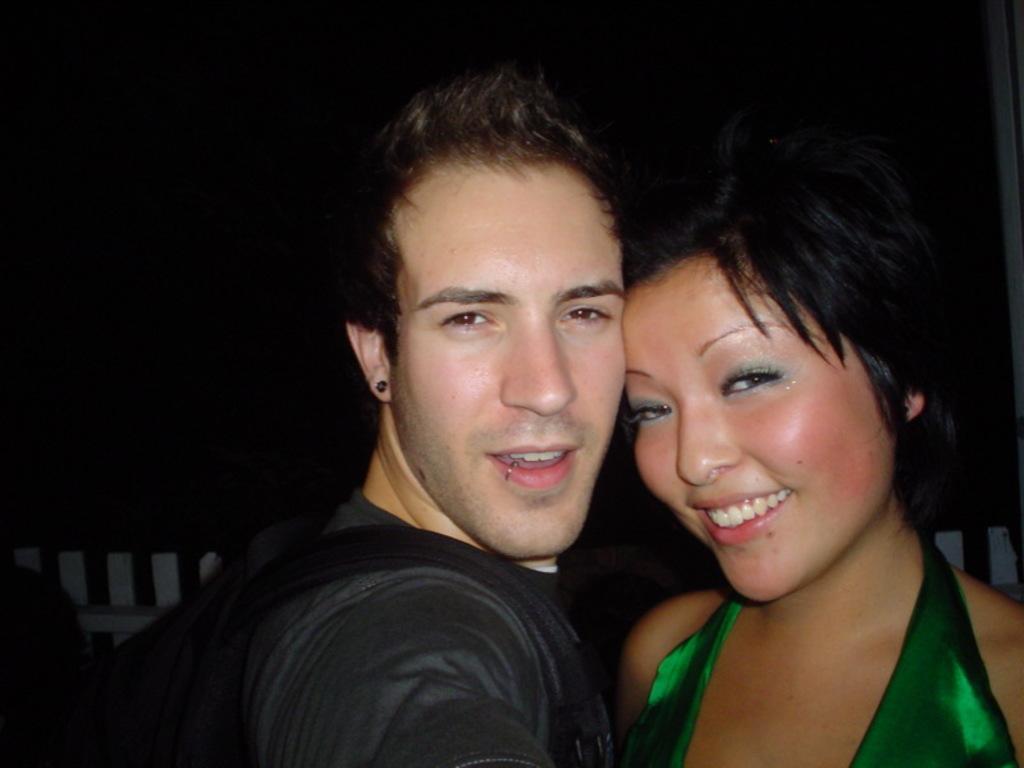Describe this image in one or two sentences. In this image we can see a man and a lady. In the background there is a fence. 